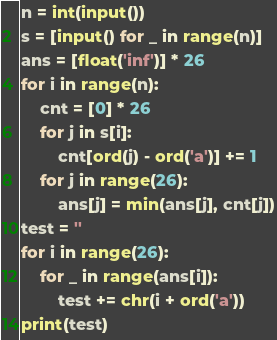Convert code to text. <code><loc_0><loc_0><loc_500><loc_500><_Python_>n = int(input())
s = [input() for _ in range(n)]
ans = [float('inf')] * 26
for i in range(n):
    cnt = [0] * 26
    for j in s[i]:
        cnt[ord(j) - ord('a')] += 1
    for j in range(26):
        ans[j] = min(ans[j], cnt[j])
test = ''
for i in range(26):
    for _ in range(ans[i]):
        test += chr(i + ord('a'))
print(test)
</code> 